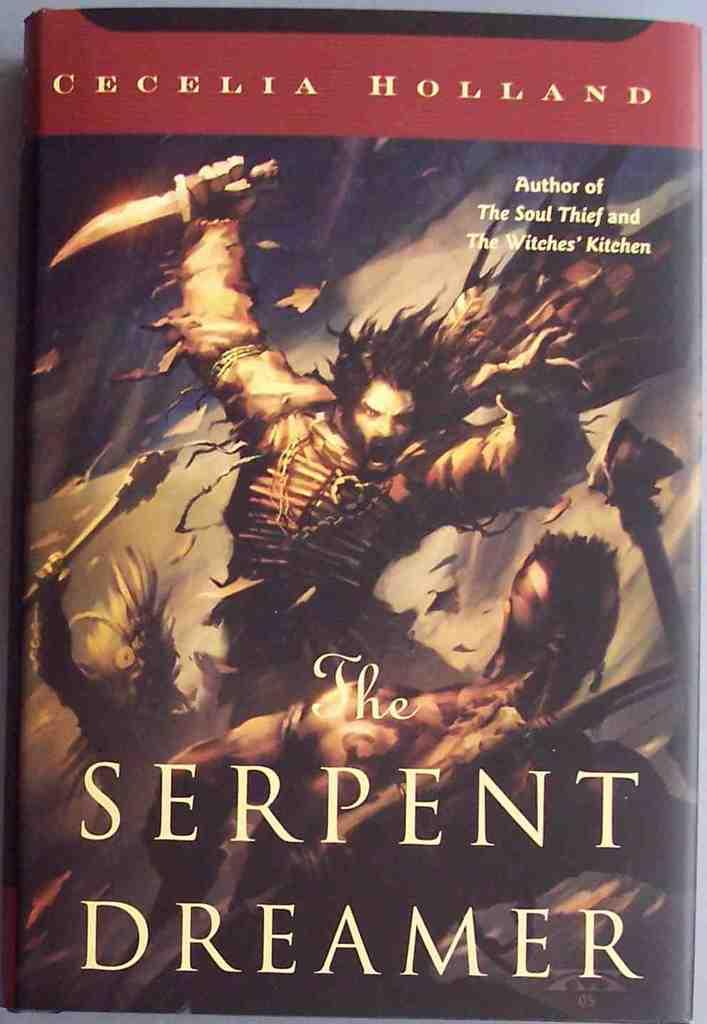What object can be seen in the image? There is a book in the image. What is visible on the book? There is text written on the book. What is depicted in the painting on the book? There is a painting of a man holding weapons in his hand on the book. What type of ear can be seen on the man in the painting on the book? There is no ear visible on the man in the painting on the book, as the painting only depicts a man holding weapons in his hand. 